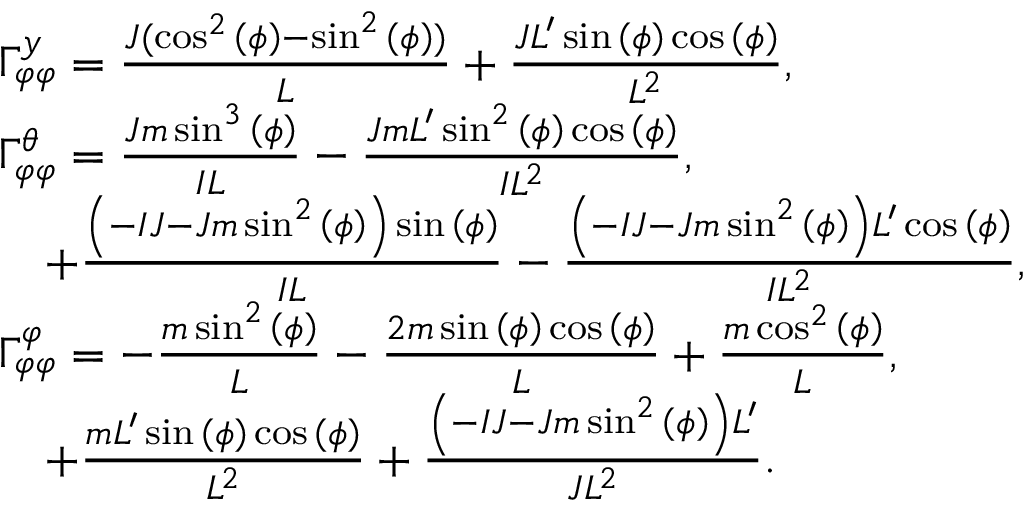Convert formula to latex. <formula><loc_0><loc_0><loc_500><loc_500>\begin{array} { r l } & { \Gamma _ { \varphi \varphi } ^ { y } = \frac { J ( \cos ^ { 2 } { \left ( \phi \right ) } - \sin ^ { 2 } { \left ( \phi \right ) } ) } { L } + \frac { J L ^ { \prime } \sin { \left ( \phi \right ) } \cos { \left ( \phi \right ) } } { L ^ { 2 } } , } \\ & { \Gamma _ { \varphi \varphi } ^ { \theta } = \frac { J m \sin ^ { 3 } { \left ( \phi \right ) } } { I L } - \frac { J m L ^ { \prime } \sin ^ { 2 } { \left ( \phi \right ) } \cos { \left ( \phi \right ) } } { I L ^ { 2 } } , } \\ & { \quad + \frac { \left ( - I J - J m \sin ^ { 2 } { \left ( \phi \right ) } \right ) \sin { \left ( \phi \right ) } } { I L } - \frac { \left ( - I J - J m \sin ^ { 2 } { \left ( \phi \right ) } \right ) L ^ { \prime } \cos { \left ( \phi \right ) } } { I L ^ { 2 } } , } \\ & { \Gamma _ { \varphi \varphi } ^ { \varphi } = - \frac { m \sin ^ { 2 } { \left ( \phi \right ) } } { L } - \frac { 2 m \sin { \left ( \phi \right ) } \cos { \left ( \phi \right ) } } { L } + \frac { m \cos ^ { 2 } { \left ( \phi \right ) } } { L } , } \\ & { \quad + \frac { m L ^ { \prime } \sin { \left ( \phi \right ) } \cos { \left ( \phi \right ) } } { L ^ { 2 } } + \frac { \left ( - I J - J m \sin ^ { 2 } { \left ( \phi \right ) } \right ) L ^ { \prime } } { J L ^ { 2 } } . } \end{array}</formula> 